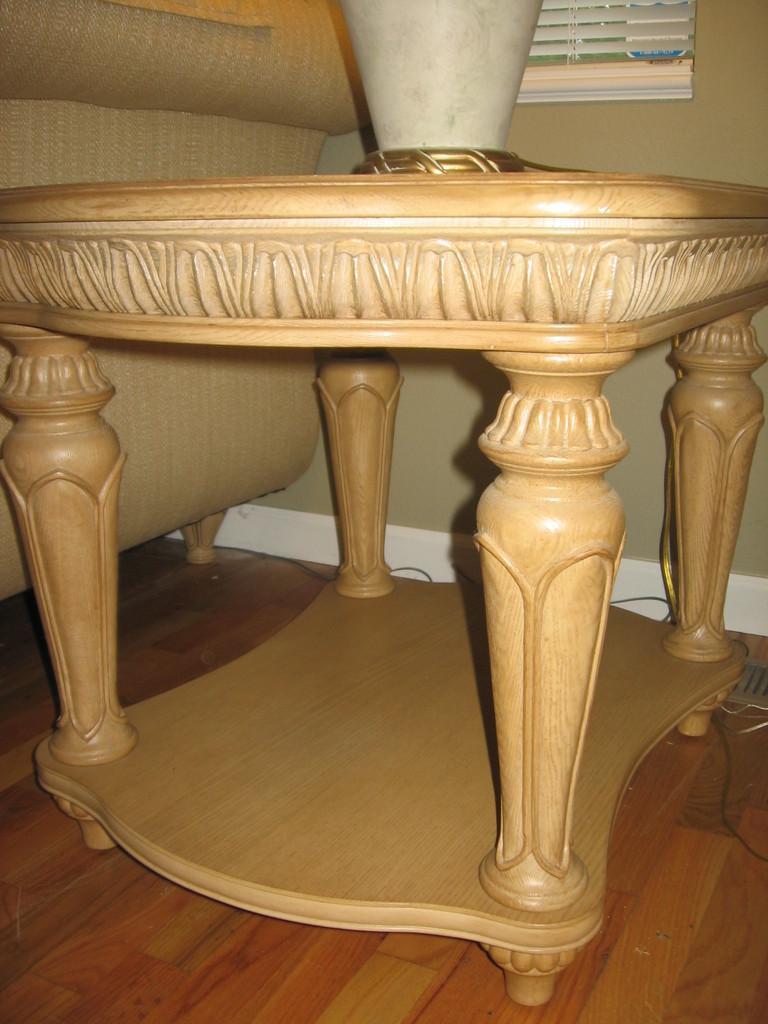How would you summarize this image in a sentence or two? In the foreground of this image, there is a table on which a pot is placed. In the background, there is a couch, window blind, cable, wall and the floor. 